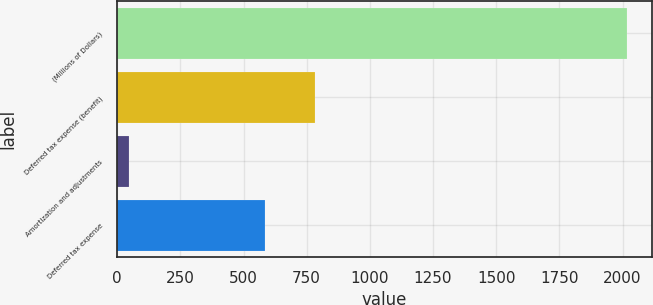<chart> <loc_0><loc_0><loc_500><loc_500><bar_chart><fcel>(Millions of Dollars)<fcel>Deferred tax expense (benefit)<fcel>Amortization and adjustments<fcel>Deferred tax expense<nl><fcel>2016<fcel>784.1<fcel>45<fcel>587<nl></chart> 